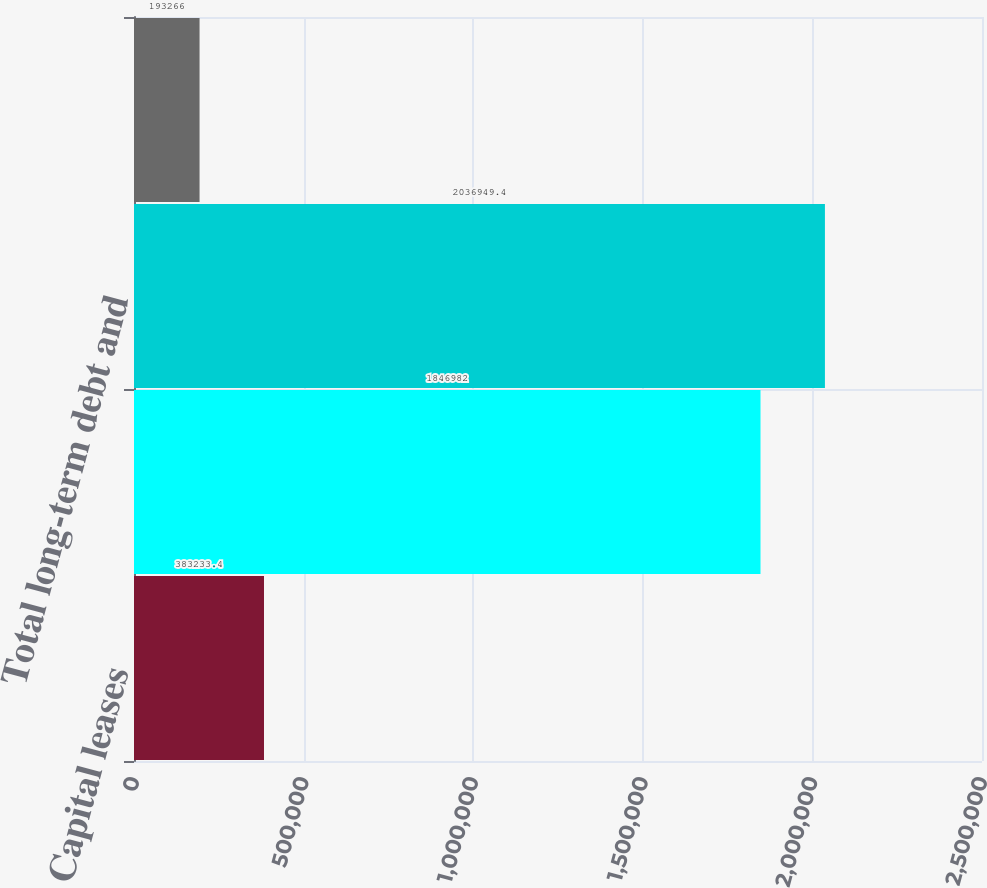Convert chart. <chart><loc_0><loc_0><loc_500><loc_500><bar_chart><fcel>Capital leases<fcel>Long-term debt (excluding<fcel>Total long-term debt and<fcel>Less current portion<nl><fcel>383233<fcel>1.84698e+06<fcel>2.03695e+06<fcel>193266<nl></chart> 